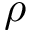<formula> <loc_0><loc_0><loc_500><loc_500>\rho</formula> 